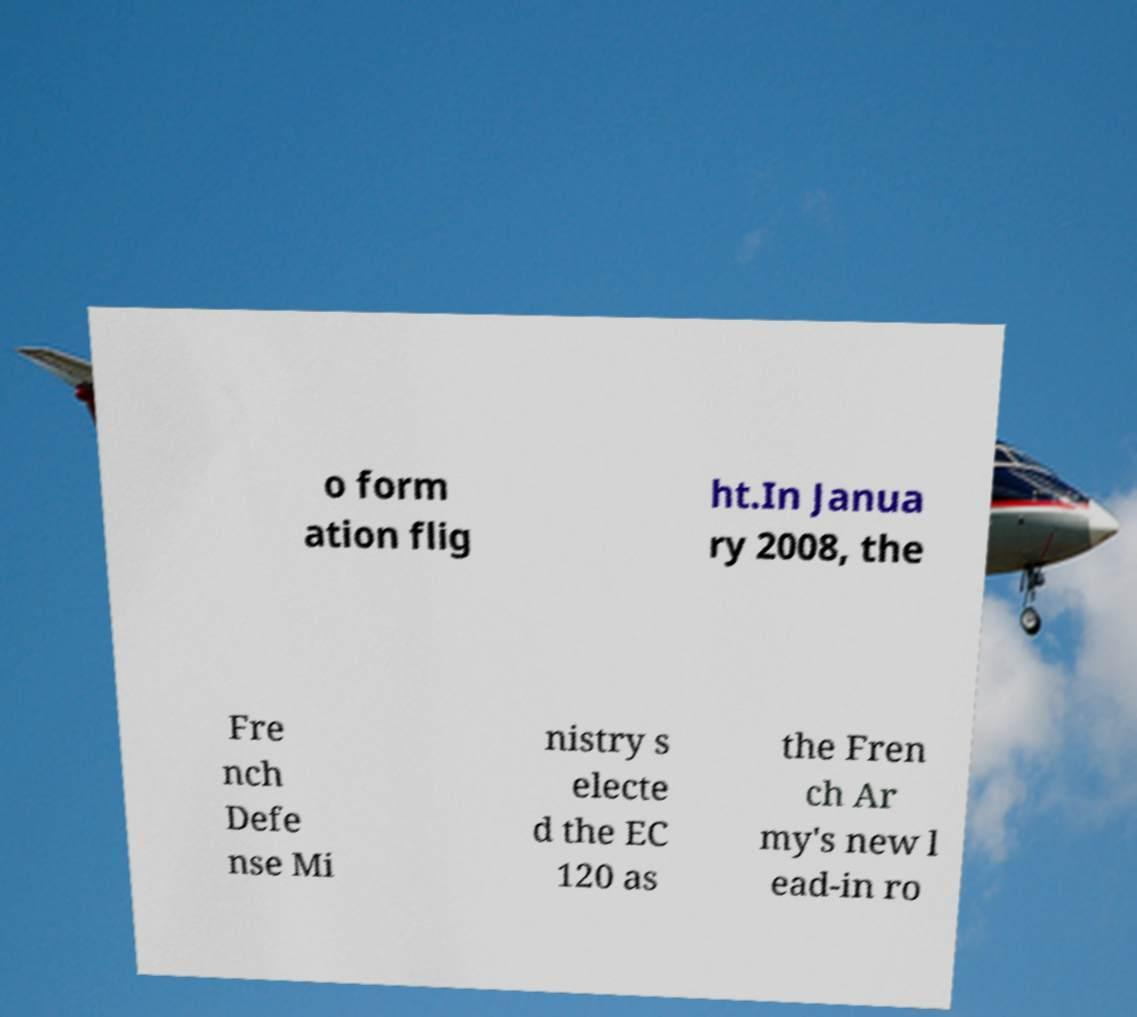Can you read and provide the text displayed in the image?This photo seems to have some interesting text. Can you extract and type it out for me? o form ation flig ht.In Janua ry 2008, the Fre nch Defe nse Mi nistry s electe d the EC 120 as the Fren ch Ar my's new l ead-in ro 